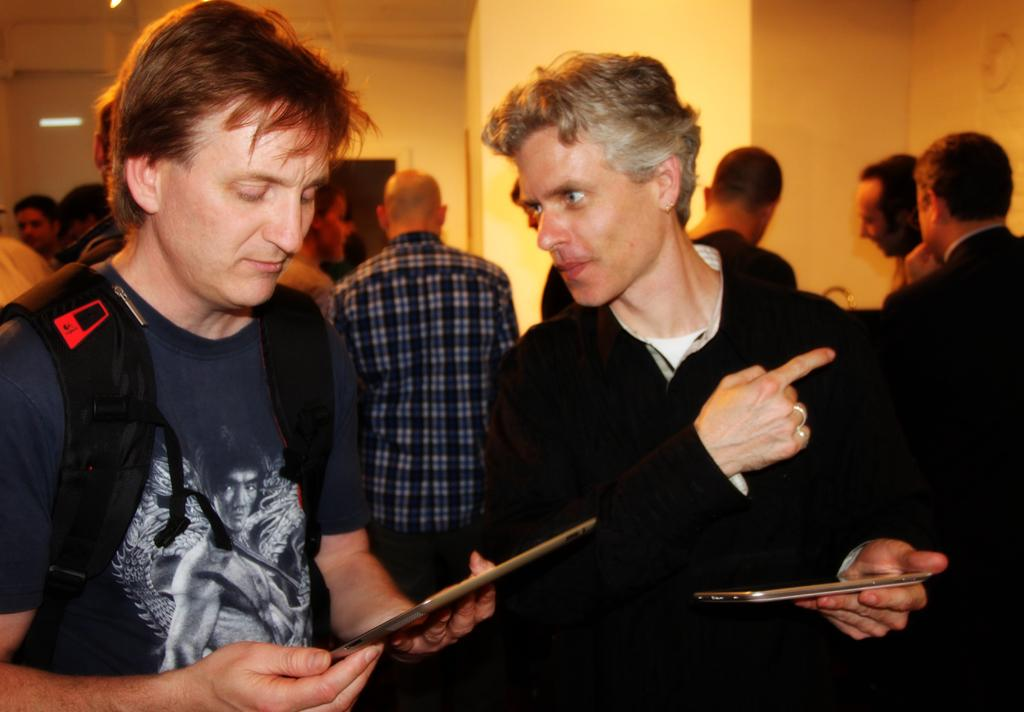What are the two persons holding in the image? The two persons are holding a tablet. Can you describe the attire of one of the persons? One person is wearing a backpack. What can be seen in the background of the image? There are other people and a wall in the background. Are there any architectural features visible in the background? Yes, there is a beam in the background. What type of ice can be seen melting on the tablet in the image? There is no ice present in the image; the two persons are holding a tablet. Can you hear the kitten crying in the image? There is no kitten or any sound mentioned in the image, so it cannot be determined if a kitten is crying. 